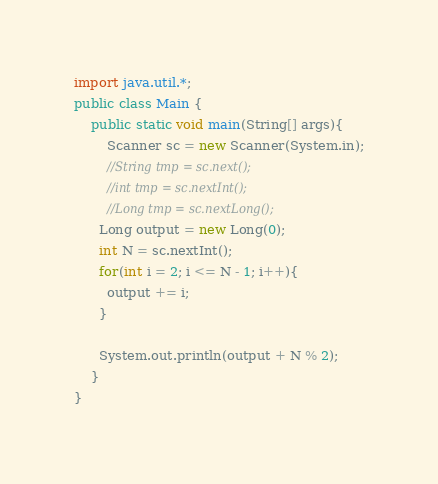<code> <loc_0><loc_0><loc_500><loc_500><_Java_>import java.util.*;
public class Main {
	public static void main(String[] args){
		Scanner sc = new Scanner(System.in);
		//String tmp = sc.next();
		//int tmp = sc.nextInt();
		//Long tmp = sc.nextLong();
      Long output = new Long(0);
      int N = sc.nextInt();
      for(int i = 2; i <= N - 1; i++){
        output += i;
      }
      
      System.out.println(output + N % 2);
	}
}
</code> 